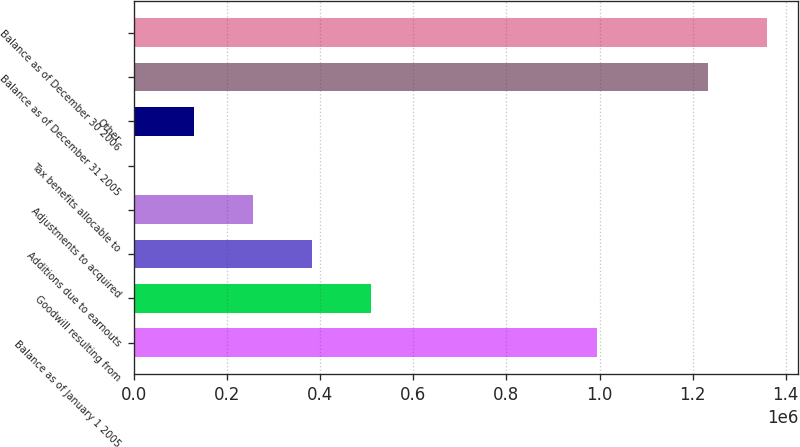Convert chart. <chart><loc_0><loc_0><loc_500><loc_500><bar_chart><fcel>Balance as of January 1 2005<fcel>Goodwill resulting from<fcel>Additions due to earnouts<fcel>Adjustments to acquired<fcel>Tax benefits allocable to<fcel>Other<fcel>Balance as of December 31 2005<fcel>Balance as of December 30 2006<nl><fcel>995065<fcel>508279<fcel>381729<fcel>255179<fcel>2079<fcel>128629<fcel>1.23293e+06<fcel>1.35948e+06<nl></chart> 